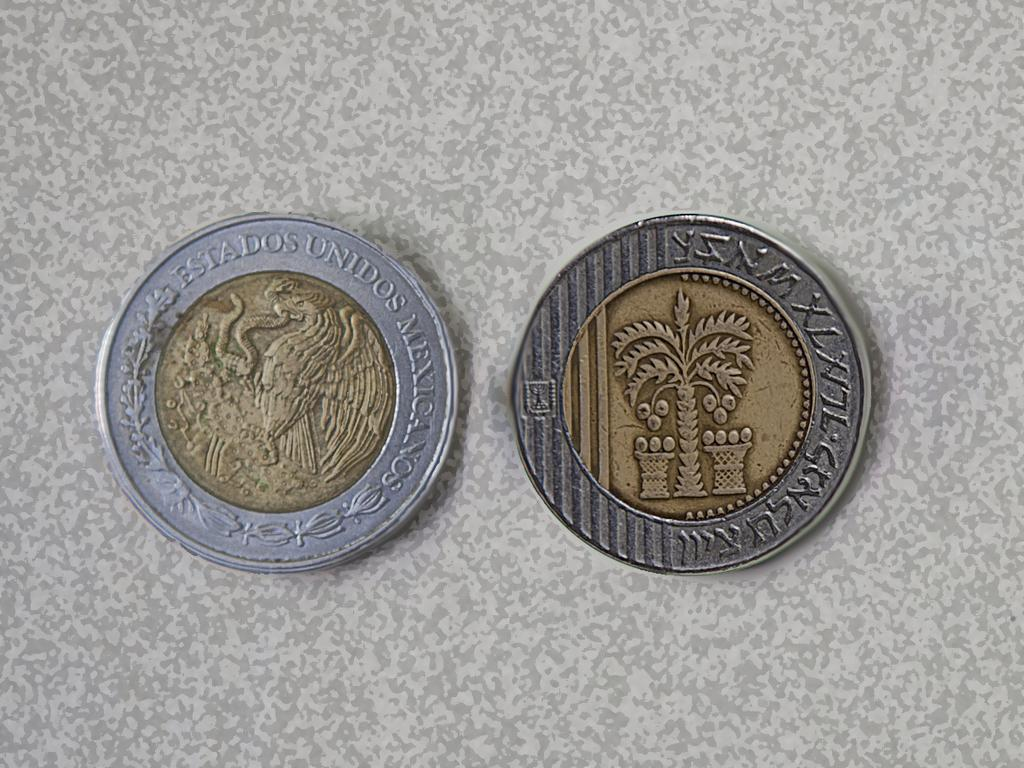<image>
Summarize the visual content of the image. The front and back of a coin with gold centers and silver bands transcribe with Estados Unidos Mexicanos. 